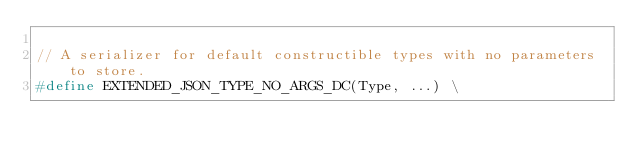<code> <loc_0><loc_0><loc_500><loc_500><_C_>
// A serializer for default constructible types with no parameters to store.
#define EXTENDED_JSON_TYPE_NO_ARGS_DC(Type, ...) \</code> 